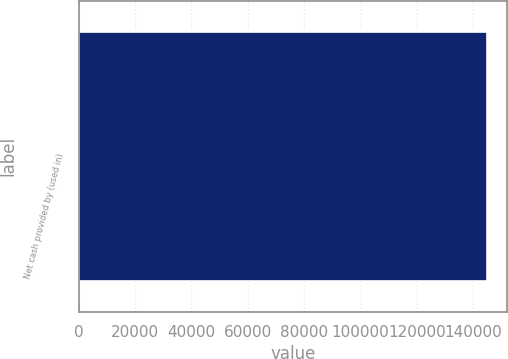Convert chart. <chart><loc_0><loc_0><loc_500><loc_500><bar_chart><fcel>Net cash provided by (used in)<nl><fcel>144731<nl></chart> 